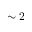<formula> <loc_0><loc_0><loc_500><loc_500>\sim 2</formula> 